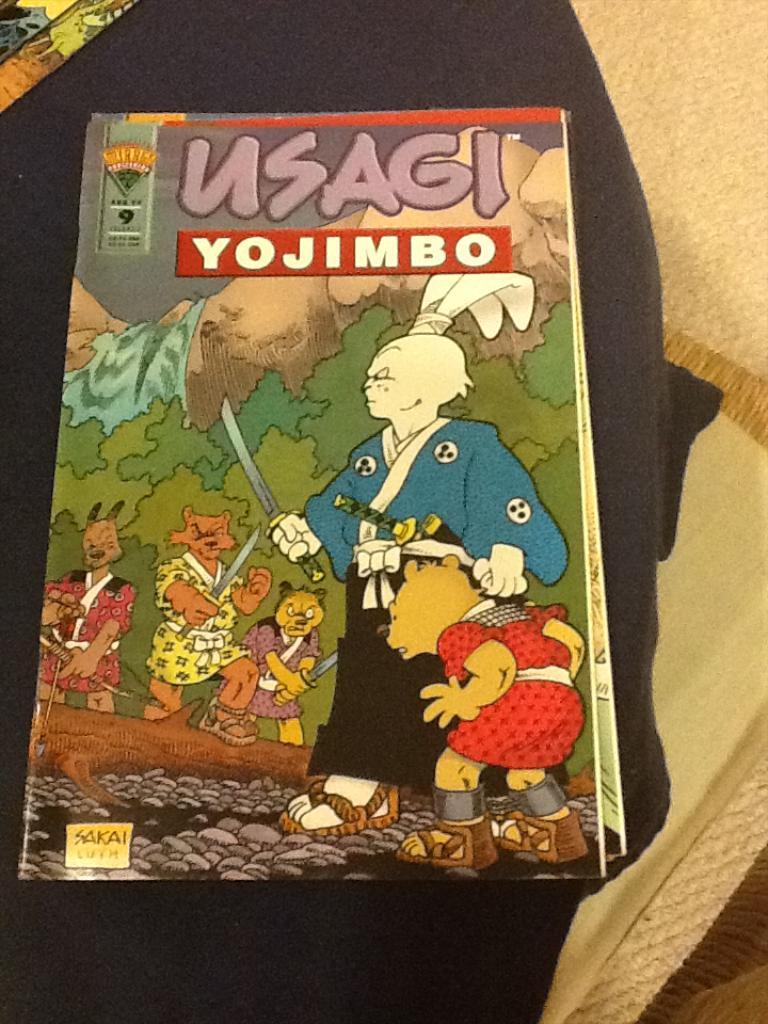What's the name of the book?
Make the answer very short. Usagi yojimbo. Who wrote the book?
Provide a succinct answer. Sakai. 